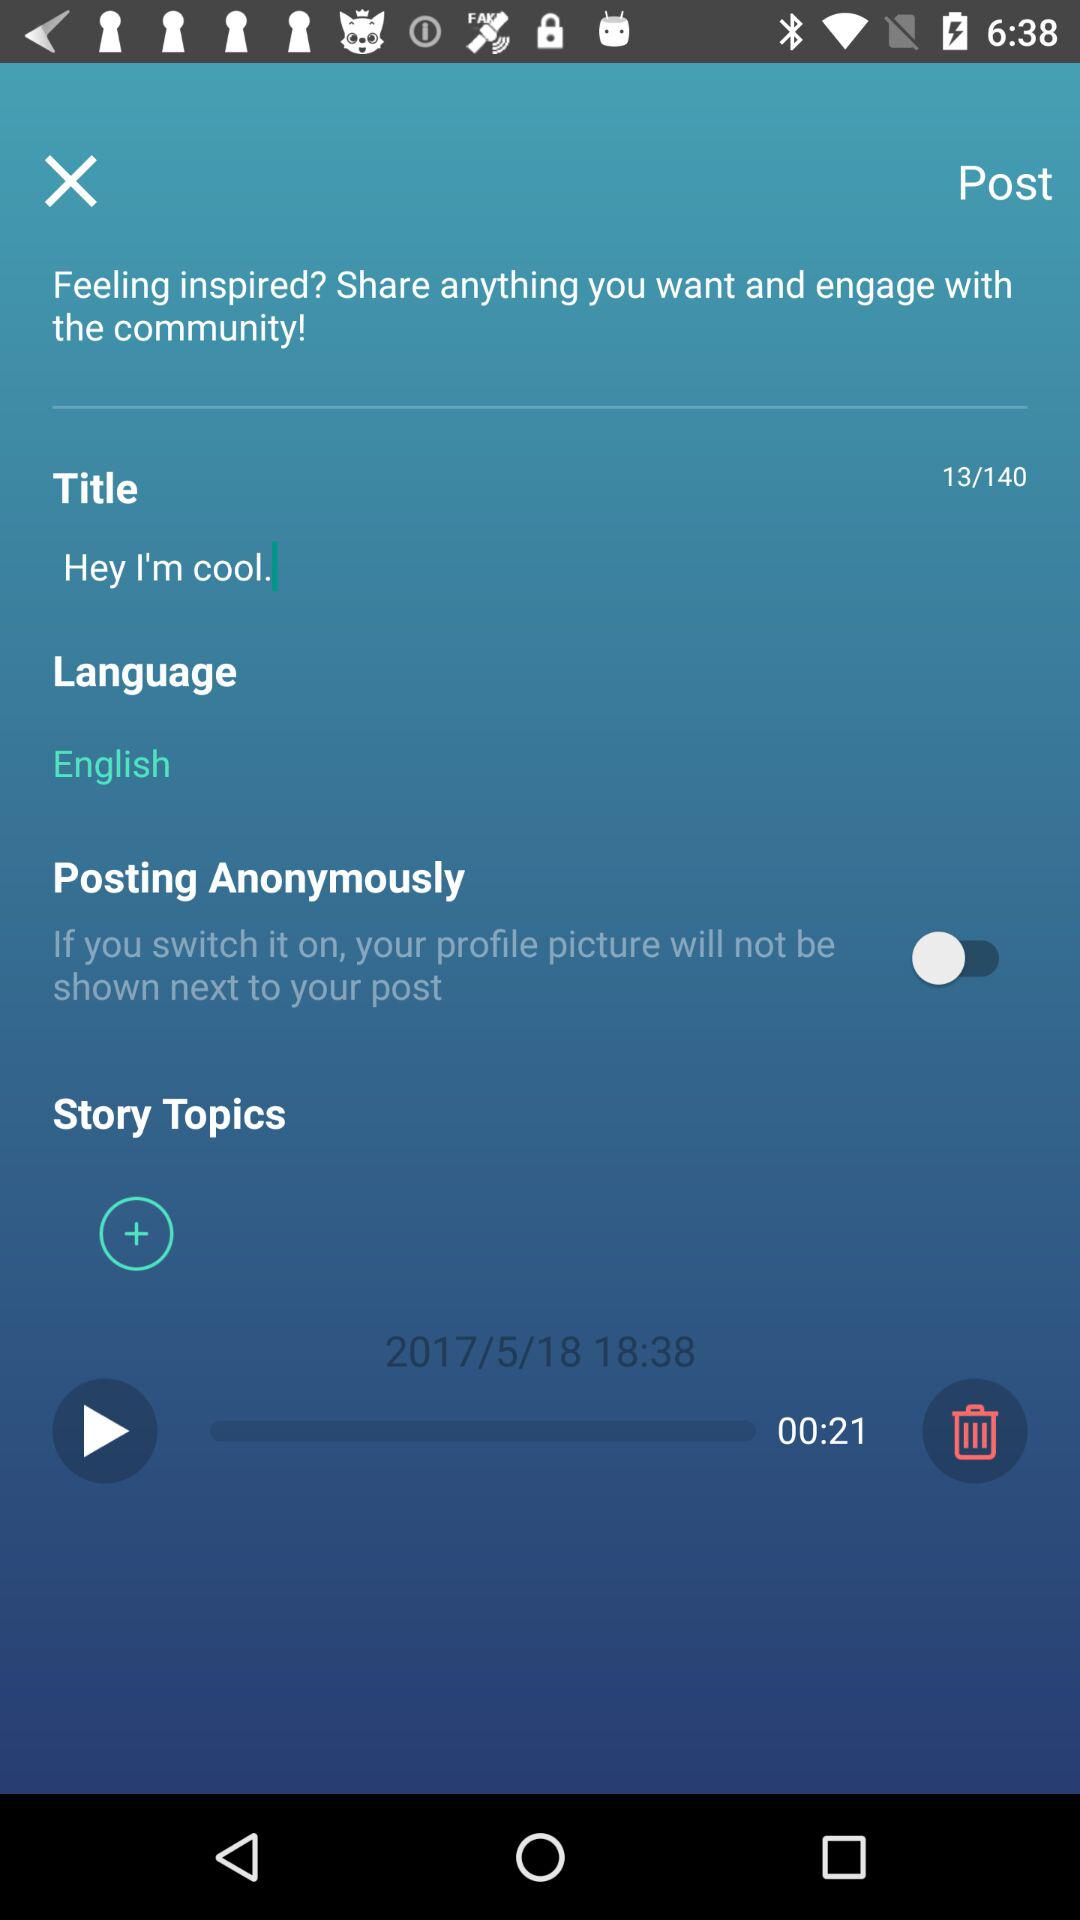What is the title of the story? The title of the story is "Hey I'm cool.". 